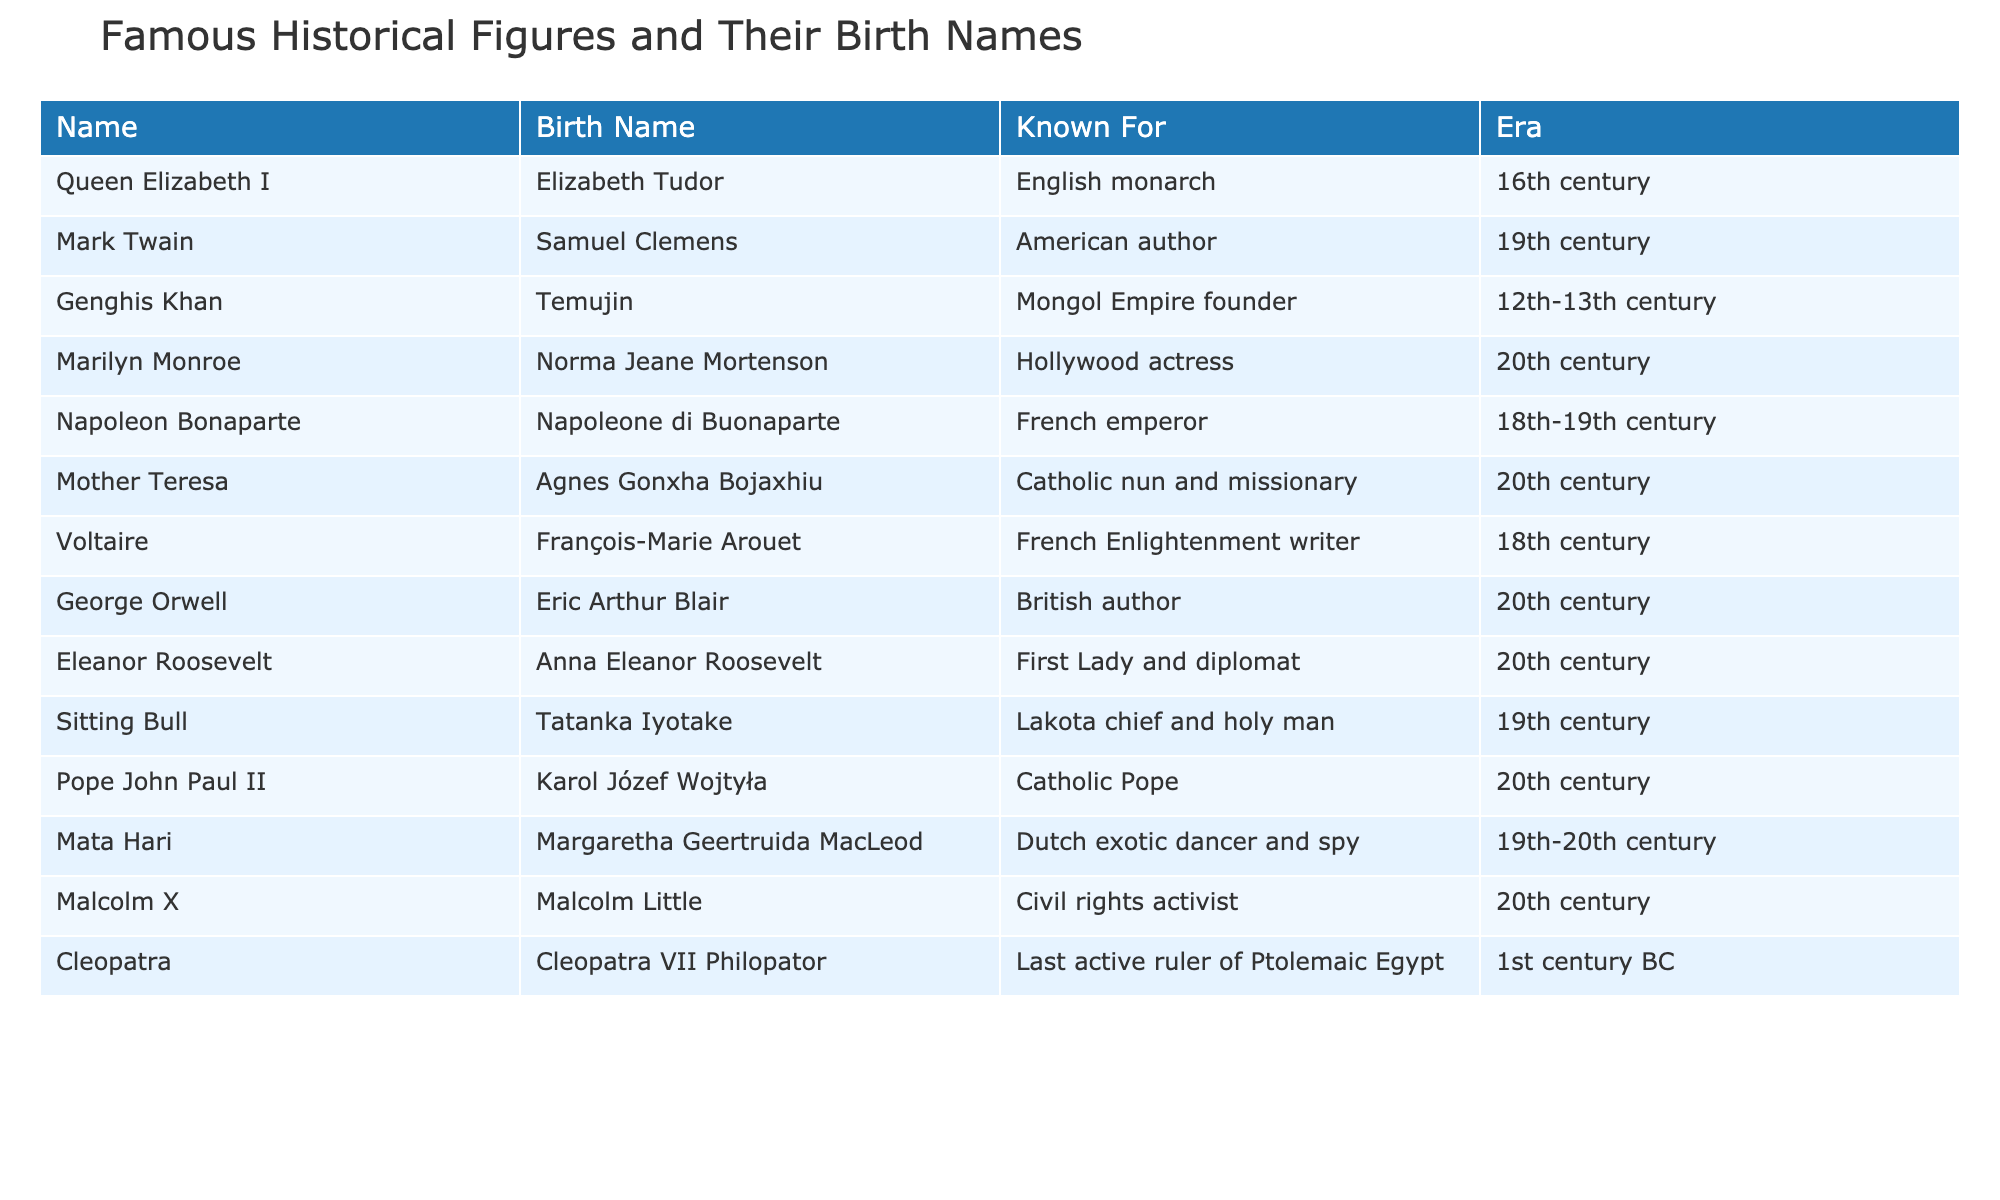What is the birth name of Queen Elizabeth I? The table lists Queen Elizabeth I under the "Name" column, and her corresponding "Birth Name" is provided right next to her, which is Elizabeth Tudor.
Answer: Elizabeth Tudor Who is known for being a Catholic Pope? By examining the table, Pope John Paul II is identified in the "Name" column, and his known profession as a "Catholic Pope" is stated in the "Known For" column.
Answer: Pope John Paul II What century did Genghis Khan live in? The table indicates the "Era" of Genghis Khan in the respective column, which states that he lived during the 12th-13th century.
Answer: 12th-13th century Is the birth name of Marilyn Monroe listed as Norma Jeane Mortenson? The table directly connects the name Marilyn Monroe to her birth name in the "Birth Name" column, confirming that it is indeed Norma Jeane Mortenson.
Answer: True How many figures from the 20th century are listed in the table? By counting the entries under the "Era" column, we find that there are six figures associated with the 20th century: Marilyn Monroe, Mother Teresa, George Orwell, Eleanor Roosevelt, Pope John Paul II, and Malcolm X.
Answer: 6 Which famous historical figure's birth name reflects their original ethnicity, based on this table? By analyzing the "Birth Name" column, we see that "Karol Józef Wojtyła" reflects Polish origins, indicating an ethnic connection. Thus, Pope John Paul II's birth name represents his ethnicity.
Answer: Pope John Paul II Which two figures were known for authorship or writing, and in what centuries did they live? The two figures are Mark Twain, known for his writing in the 19th century, and George Orwell, who authored works in the 20th century. Thus, the two names are identified, along with their respective centuries.
Answer: Mark Twain (19th century), George Orwell (20th century) Who among these figures had the longest span of years between their birth name and their recognized name? To determine this, we look for the earliest born figure by their birth name, which is Cleopatra (1st century BC), and compare it to the latest recognized name, which is Marilyn Monroe (20th century). Cleopatra's time represents a vast gap, possibly surpassing others listed.
Answer: Cleopatra (1st century BC) What is the relationship between Sitting Bull's name and his birth name? From the table, Sitting Bull is the name he is recognized by in history, while his birth name is Tatanka Iyotake. They are directly connected in the table, indicating their identification as the same individual.
Answer: They are the same individual Are there more figures from the 19th century or the 20th century? Upon counting, we find there are three figures from the 19th century (Sitting Bull, Malcolm X, and Genghis Khan) and six from the 20th century, thus indicating a greater quantity from the 20th century.
Answer: 20th century has more figures What profession is associated with Mata Hari, as per the table? The table indicates the "Known For" column, stating that Mata Hari was known as a Dutch exotic dancer and spy, reflecting her dual profession.
Answer: Exotic dancer and spy 